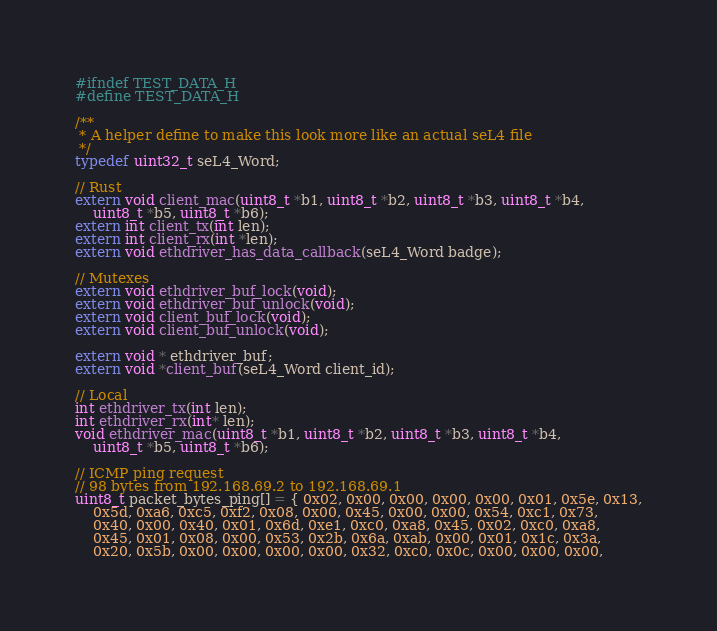<code> <loc_0><loc_0><loc_500><loc_500><_C_>#ifndef TEST_DATA_H
#define TEST_DATA_H

/**
 * A helper define to make this look more like an actual seL4 file
 */
typedef uint32_t seL4_Word;

// Rust
extern void client_mac(uint8_t *b1, uint8_t *b2, uint8_t *b3, uint8_t *b4,
    uint8_t *b5, uint8_t *b6);
extern int client_tx(int len);
extern int client_rx(int *len);
extern void ethdriver_has_data_callback(seL4_Word badge);

// Mutexes
extern void ethdriver_buf_lock(void);
extern void ethdriver_buf_unlock(void);
extern void client_buf_lock(void);
extern void client_buf_unlock(void);

extern void * ethdriver_buf;
extern void *client_buf(seL4_Word client_id);

// Local
int ethdriver_tx(int len);
int ethdriver_rx(int* len);
void ethdriver_mac(uint8_t *b1, uint8_t *b2, uint8_t *b3, uint8_t *b4,
    uint8_t *b5, uint8_t *b6);

// ICMP ping request
// 98 bytes from 192.168.69.2 to 192.168.69.1
uint8_t packet_bytes_ping[] = { 0x02, 0x00, 0x00, 0x00, 0x00, 0x01, 0x5e, 0x13,
    0x5d, 0xa6, 0xc5, 0xf2, 0x08, 0x00, 0x45, 0x00, 0x00, 0x54, 0xc1, 0x73,
    0x40, 0x00, 0x40, 0x01, 0x6d, 0xe1, 0xc0, 0xa8, 0x45, 0x02, 0xc0, 0xa8,
    0x45, 0x01, 0x08, 0x00, 0x53, 0x2b, 0x6a, 0xab, 0x00, 0x01, 0x1c, 0x3a,
    0x20, 0x5b, 0x00, 0x00, 0x00, 0x00, 0x32, 0xc0, 0x0c, 0x00, 0x00, 0x00,</code> 